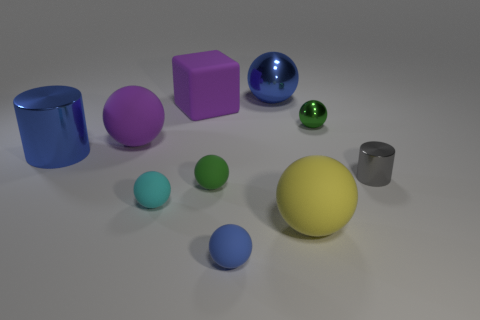Subtract all yellow matte balls. How many balls are left? 6 Subtract all green spheres. How many spheres are left? 5 Subtract all yellow cylinders. How many blue balls are left? 2 Subtract all blocks. How many objects are left? 9 Subtract 6 balls. How many balls are left? 1 Add 9 big metal cylinders. How many big metal cylinders are left? 10 Add 3 large cyan metal balls. How many large cyan metal balls exist? 3 Subtract 0 gray balls. How many objects are left? 10 Subtract all cyan balls. Subtract all green blocks. How many balls are left? 6 Subtract all cyan metallic blocks. Subtract all small blue rubber objects. How many objects are left? 9 